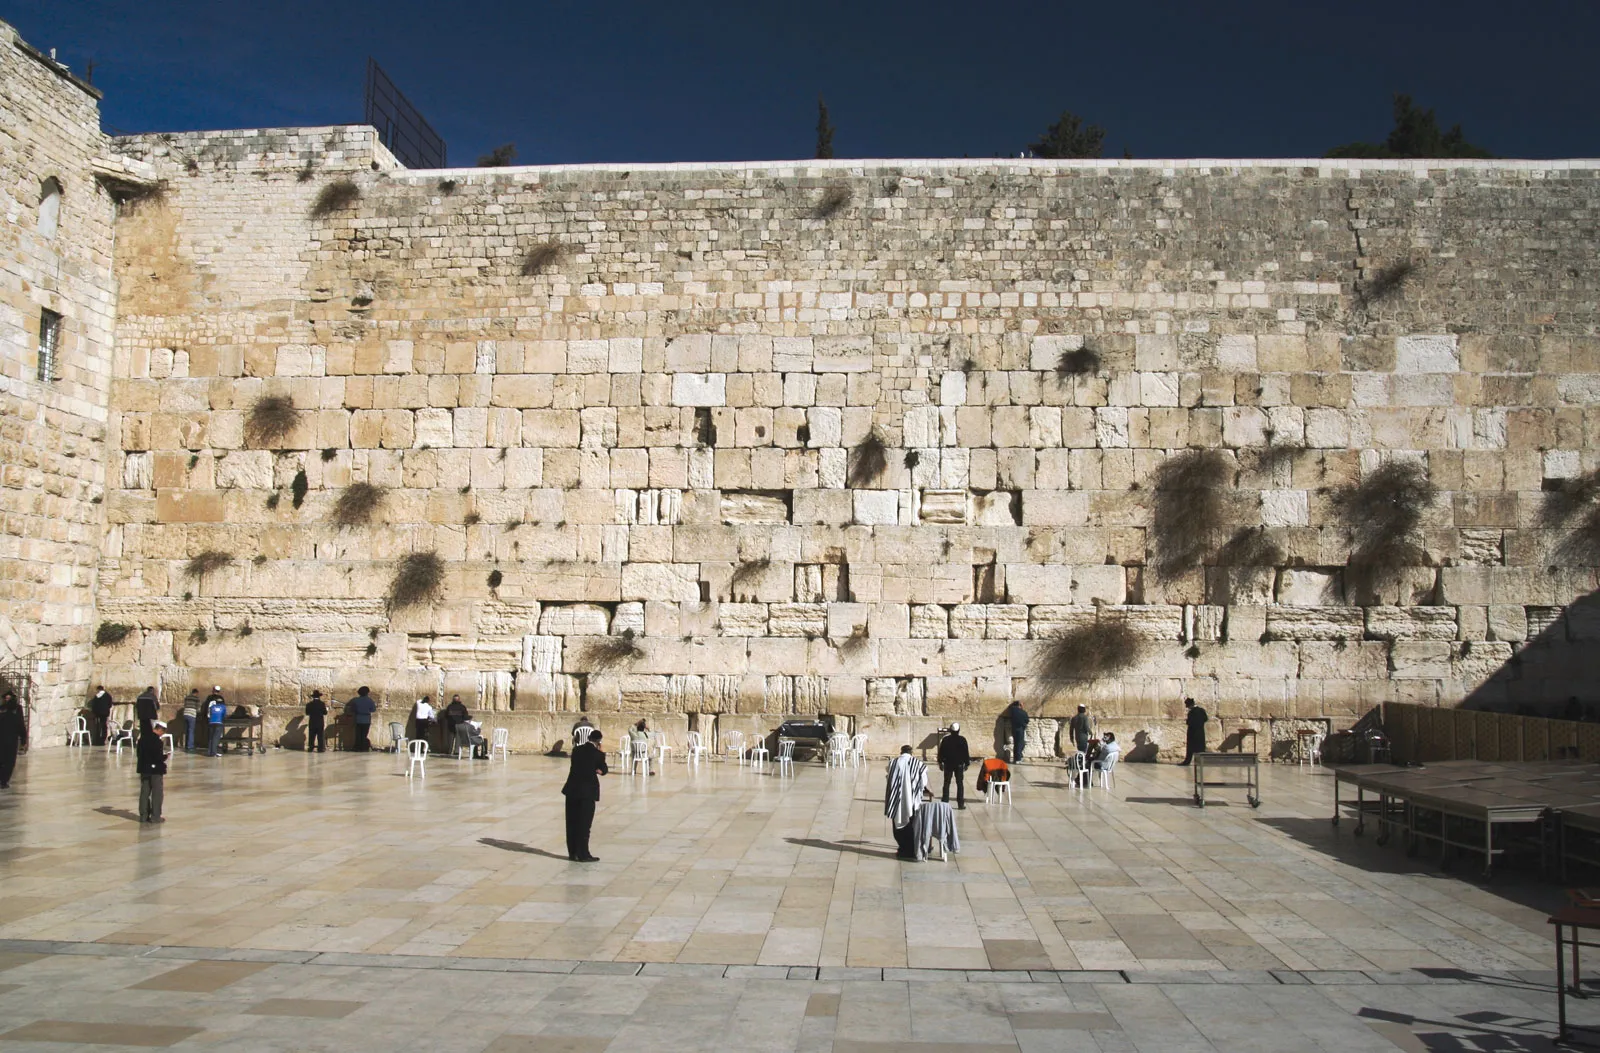What historical significance does this wall hold? The Western Wall is deeply significant in Jewish history and culture as the last remaining wall of the Second Jewish Temple, which was destroyed in 70 CE by the Romans. This site has become a place of pilgrimage and prayer, where Jews from around the world gather to reflect and connect with their heritage. The presence of notes containing prayers, tucked into the crevices of the wall, showcases its role as a spiritual bridge for those seeking divine connection and solace. 